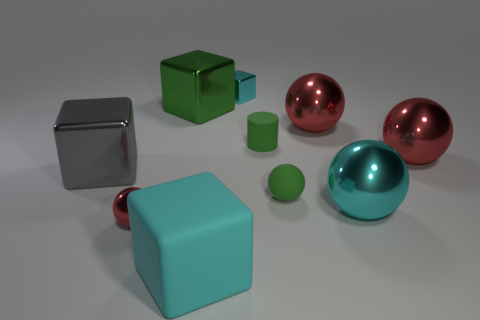There is a rubber thing in front of the red metallic sphere that is in front of the tiny ball on the right side of the cyan matte thing; what shape is it?
Your response must be concise. Cube. What number of other yellow cylinders have the same material as the cylinder?
Your answer should be compact. 0. There is a small metal object in front of the big gray metal block; what number of small cyan metallic objects are in front of it?
Provide a short and direct response. 0. There is a tiny object left of the tiny cyan thing; is it the same color as the small shiny thing that is to the right of the small red metallic sphere?
Offer a very short reply. No. There is a big object that is both to the left of the rubber block and in front of the big green metal block; what shape is it?
Provide a succinct answer. Cube. Are there any purple matte things that have the same shape as the large gray metallic thing?
Offer a very short reply. No. The green thing that is the same size as the green ball is what shape?
Provide a short and direct response. Cylinder. What material is the tiny cyan object?
Make the answer very short. Metal. How big is the cyan metallic thing in front of the gray object in front of the large metallic block that is right of the big gray metallic thing?
Your answer should be very brief. Large. There is a small ball that is the same color as the matte cylinder; what is its material?
Offer a terse response. Rubber. 